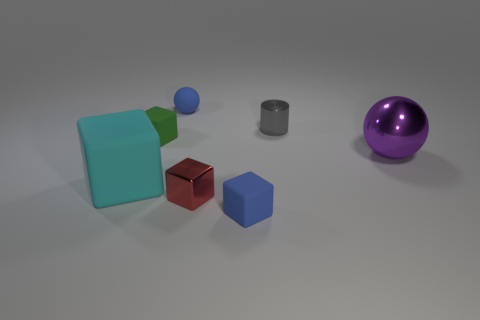Subtract 1 blocks. How many blocks are left? 3 Subtract all gray cubes. Subtract all cyan cylinders. How many cubes are left? 4 Add 1 small blue cubes. How many objects exist? 8 Subtract all cubes. How many objects are left? 3 Subtract 0 gray blocks. How many objects are left? 7 Subtract all metallic blocks. Subtract all blue rubber cubes. How many objects are left? 5 Add 3 tiny metal cylinders. How many tiny metal cylinders are left? 4 Add 3 small red rubber balls. How many small red rubber balls exist? 3 